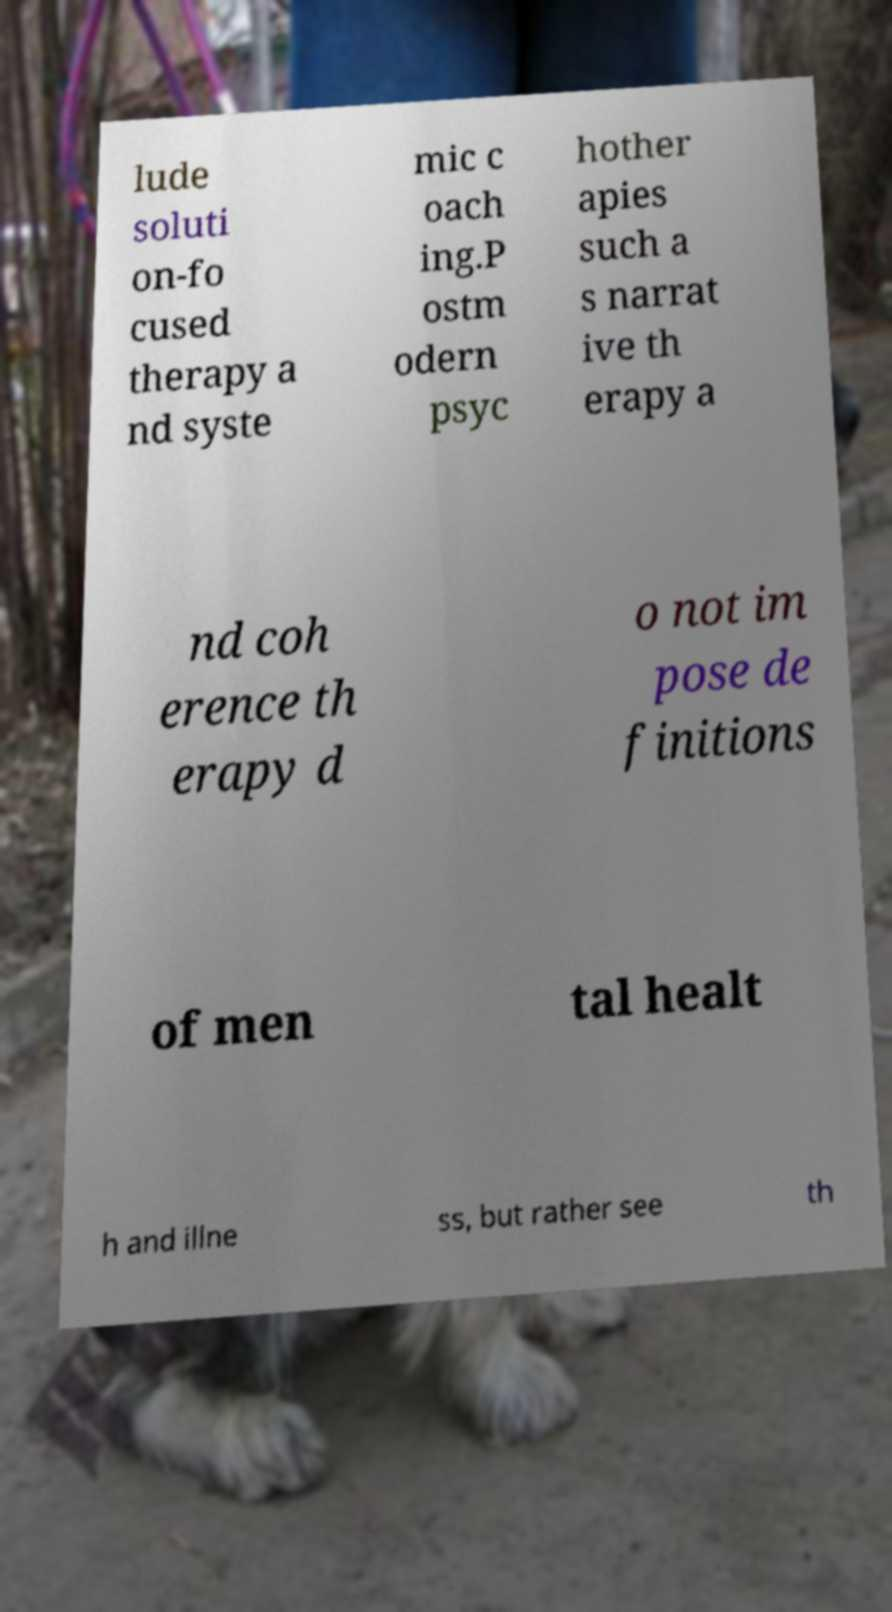Could you extract and type out the text from this image? lude soluti on-fo cused therapy a nd syste mic c oach ing.P ostm odern psyc hother apies such a s narrat ive th erapy a nd coh erence th erapy d o not im pose de finitions of men tal healt h and illne ss, but rather see th 